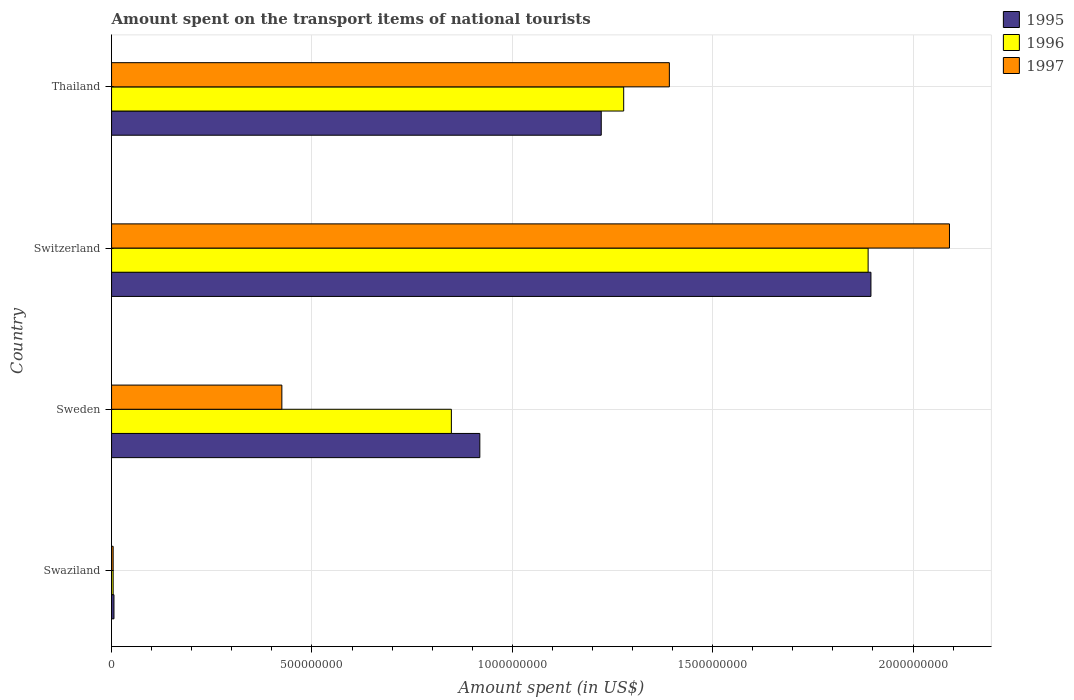How many different coloured bars are there?
Provide a succinct answer. 3. Are the number of bars on each tick of the Y-axis equal?
Your answer should be very brief. Yes. What is the label of the 3rd group of bars from the top?
Ensure brevity in your answer.  Sweden. In how many cases, is the number of bars for a given country not equal to the number of legend labels?
Offer a very short reply. 0. What is the amount spent on the transport items of national tourists in 1996 in Switzerland?
Keep it short and to the point. 1.89e+09. Across all countries, what is the maximum amount spent on the transport items of national tourists in 1997?
Your answer should be compact. 2.09e+09. In which country was the amount spent on the transport items of national tourists in 1997 maximum?
Provide a short and direct response. Switzerland. In which country was the amount spent on the transport items of national tourists in 1997 minimum?
Provide a succinct answer. Swaziland. What is the total amount spent on the transport items of national tourists in 1996 in the graph?
Your response must be concise. 4.02e+09. What is the difference between the amount spent on the transport items of national tourists in 1996 in Swaziland and that in Sweden?
Make the answer very short. -8.44e+08. What is the difference between the amount spent on the transport items of national tourists in 1997 in Thailand and the amount spent on the transport items of national tourists in 1996 in Switzerland?
Keep it short and to the point. -4.96e+08. What is the average amount spent on the transport items of national tourists in 1996 per country?
Your answer should be compact. 1.00e+09. What is the difference between the amount spent on the transport items of national tourists in 1995 and amount spent on the transport items of national tourists in 1996 in Sweden?
Make the answer very short. 7.10e+07. In how many countries, is the amount spent on the transport items of national tourists in 1997 greater than 2000000000 US$?
Offer a terse response. 1. What is the ratio of the amount spent on the transport items of national tourists in 1997 in Sweden to that in Thailand?
Keep it short and to the point. 0.31. What is the difference between the highest and the second highest amount spent on the transport items of national tourists in 1996?
Offer a terse response. 6.10e+08. What is the difference between the highest and the lowest amount spent on the transport items of national tourists in 1995?
Your answer should be very brief. 1.89e+09. What does the 3rd bar from the bottom in Swaziland represents?
Provide a succinct answer. 1997. Is it the case that in every country, the sum of the amount spent on the transport items of national tourists in 1997 and amount spent on the transport items of national tourists in 1995 is greater than the amount spent on the transport items of national tourists in 1996?
Offer a terse response. Yes. Are all the bars in the graph horizontal?
Offer a very short reply. Yes. Does the graph contain any zero values?
Provide a succinct answer. No. Does the graph contain grids?
Provide a short and direct response. Yes. Where does the legend appear in the graph?
Your response must be concise. Top right. How many legend labels are there?
Your answer should be compact. 3. What is the title of the graph?
Provide a succinct answer. Amount spent on the transport items of national tourists. Does "2007" appear as one of the legend labels in the graph?
Offer a very short reply. No. What is the label or title of the X-axis?
Provide a succinct answer. Amount spent (in US$). What is the label or title of the Y-axis?
Ensure brevity in your answer.  Country. What is the Amount spent (in US$) in 1995 in Swaziland?
Give a very brief answer. 6.00e+06. What is the Amount spent (in US$) in 1997 in Swaziland?
Offer a very short reply. 4.00e+06. What is the Amount spent (in US$) in 1995 in Sweden?
Your answer should be compact. 9.19e+08. What is the Amount spent (in US$) of 1996 in Sweden?
Provide a short and direct response. 8.48e+08. What is the Amount spent (in US$) in 1997 in Sweden?
Offer a terse response. 4.25e+08. What is the Amount spent (in US$) in 1995 in Switzerland?
Your answer should be compact. 1.90e+09. What is the Amount spent (in US$) of 1996 in Switzerland?
Your response must be concise. 1.89e+09. What is the Amount spent (in US$) of 1997 in Switzerland?
Keep it short and to the point. 2.09e+09. What is the Amount spent (in US$) of 1995 in Thailand?
Your response must be concise. 1.22e+09. What is the Amount spent (in US$) of 1996 in Thailand?
Make the answer very short. 1.28e+09. What is the Amount spent (in US$) of 1997 in Thailand?
Your response must be concise. 1.39e+09. Across all countries, what is the maximum Amount spent (in US$) in 1995?
Provide a short and direct response. 1.90e+09. Across all countries, what is the maximum Amount spent (in US$) in 1996?
Your answer should be compact. 1.89e+09. Across all countries, what is the maximum Amount spent (in US$) in 1997?
Your response must be concise. 2.09e+09. Across all countries, what is the minimum Amount spent (in US$) in 1997?
Your response must be concise. 4.00e+06. What is the total Amount spent (in US$) in 1995 in the graph?
Offer a very short reply. 4.04e+09. What is the total Amount spent (in US$) of 1996 in the graph?
Offer a terse response. 4.02e+09. What is the total Amount spent (in US$) in 1997 in the graph?
Your answer should be compact. 3.91e+09. What is the difference between the Amount spent (in US$) in 1995 in Swaziland and that in Sweden?
Your answer should be very brief. -9.13e+08. What is the difference between the Amount spent (in US$) in 1996 in Swaziland and that in Sweden?
Keep it short and to the point. -8.44e+08. What is the difference between the Amount spent (in US$) in 1997 in Swaziland and that in Sweden?
Offer a terse response. -4.21e+08. What is the difference between the Amount spent (in US$) in 1995 in Swaziland and that in Switzerland?
Your response must be concise. -1.89e+09. What is the difference between the Amount spent (in US$) in 1996 in Swaziland and that in Switzerland?
Ensure brevity in your answer.  -1.88e+09. What is the difference between the Amount spent (in US$) in 1997 in Swaziland and that in Switzerland?
Provide a succinct answer. -2.09e+09. What is the difference between the Amount spent (in US$) in 1995 in Swaziland and that in Thailand?
Ensure brevity in your answer.  -1.22e+09. What is the difference between the Amount spent (in US$) in 1996 in Swaziland and that in Thailand?
Your answer should be compact. -1.27e+09. What is the difference between the Amount spent (in US$) in 1997 in Swaziland and that in Thailand?
Provide a succinct answer. -1.39e+09. What is the difference between the Amount spent (in US$) of 1995 in Sweden and that in Switzerland?
Provide a short and direct response. -9.76e+08. What is the difference between the Amount spent (in US$) in 1996 in Sweden and that in Switzerland?
Offer a terse response. -1.04e+09. What is the difference between the Amount spent (in US$) of 1997 in Sweden and that in Switzerland?
Keep it short and to the point. -1.67e+09. What is the difference between the Amount spent (in US$) in 1995 in Sweden and that in Thailand?
Your answer should be compact. -3.03e+08. What is the difference between the Amount spent (in US$) in 1996 in Sweden and that in Thailand?
Offer a very short reply. -4.30e+08. What is the difference between the Amount spent (in US$) of 1997 in Sweden and that in Thailand?
Offer a terse response. -9.67e+08. What is the difference between the Amount spent (in US$) of 1995 in Switzerland and that in Thailand?
Your answer should be compact. 6.73e+08. What is the difference between the Amount spent (in US$) in 1996 in Switzerland and that in Thailand?
Your response must be concise. 6.10e+08. What is the difference between the Amount spent (in US$) of 1997 in Switzerland and that in Thailand?
Your answer should be very brief. 6.99e+08. What is the difference between the Amount spent (in US$) of 1995 in Swaziland and the Amount spent (in US$) of 1996 in Sweden?
Provide a short and direct response. -8.42e+08. What is the difference between the Amount spent (in US$) of 1995 in Swaziland and the Amount spent (in US$) of 1997 in Sweden?
Give a very brief answer. -4.19e+08. What is the difference between the Amount spent (in US$) of 1996 in Swaziland and the Amount spent (in US$) of 1997 in Sweden?
Your answer should be very brief. -4.21e+08. What is the difference between the Amount spent (in US$) in 1995 in Swaziland and the Amount spent (in US$) in 1996 in Switzerland?
Ensure brevity in your answer.  -1.88e+09. What is the difference between the Amount spent (in US$) of 1995 in Swaziland and the Amount spent (in US$) of 1997 in Switzerland?
Provide a short and direct response. -2.08e+09. What is the difference between the Amount spent (in US$) in 1996 in Swaziland and the Amount spent (in US$) in 1997 in Switzerland?
Your answer should be compact. -2.09e+09. What is the difference between the Amount spent (in US$) in 1995 in Swaziland and the Amount spent (in US$) in 1996 in Thailand?
Offer a very short reply. -1.27e+09. What is the difference between the Amount spent (in US$) in 1995 in Swaziland and the Amount spent (in US$) in 1997 in Thailand?
Make the answer very short. -1.39e+09. What is the difference between the Amount spent (in US$) of 1996 in Swaziland and the Amount spent (in US$) of 1997 in Thailand?
Your answer should be very brief. -1.39e+09. What is the difference between the Amount spent (in US$) in 1995 in Sweden and the Amount spent (in US$) in 1996 in Switzerland?
Provide a short and direct response. -9.69e+08. What is the difference between the Amount spent (in US$) in 1995 in Sweden and the Amount spent (in US$) in 1997 in Switzerland?
Offer a terse response. -1.17e+09. What is the difference between the Amount spent (in US$) in 1996 in Sweden and the Amount spent (in US$) in 1997 in Switzerland?
Provide a succinct answer. -1.24e+09. What is the difference between the Amount spent (in US$) in 1995 in Sweden and the Amount spent (in US$) in 1996 in Thailand?
Your answer should be very brief. -3.59e+08. What is the difference between the Amount spent (in US$) in 1995 in Sweden and the Amount spent (in US$) in 1997 in Thailand?
Provide a short and direct response. -4.73e+08. What is the difference between the Amount spent (in US$) in 1996 in Sweden and the Amount spent (in US$) in 1997 in Thailand?
Provide a short and direct response. -5.44e+08. What is the difference between the Amount spent (in US$) in 1995 in Switzerland and the Amount spent (in US$) in 1996 in Thailand?
Give a very brief answer. 6.17e+08. What is the difference between the Amount spent (in US$) of 1995 in Switzerland and the Amount spent (in US$) of 1997 in Thailand?
Your answer should be compact. 5.03e+08. What is the difference between the Amount spent (in US$) of 1996 in Switzerland and the Amount spent (in US$) of 1997 in Thailand?
Make the answer very short. 4.96e+08. What is the average Amount spent (in US$) in 1995 per country?
Offer a terse response. 1.01e+09. What is the average Amount spent (in US$) in 1996 per country?
Offer a very short reply. 1.00e+09. What is the average Amount spent (in US$) of 1997 per country?
Your answer should be compact. 9.78e+08. What is the difference between the Amount spent (in US$) of 1995 and Amount spent (in US$) of 1996 in Swaziland?
Give a very brief answer. 2.00e+06. What is the difference between the Amount spent (in US$) in 1996 and Amount spent (in US$) in 1997 in Swaziland?
Provide a short and direct response. 0. What is the difference between the Amount spent (in US$) in 1995 and Amount spent (in US$) in 1996 in Sweden?
Make the answer very short. 7.10e+07. What is the difference between the Amount spent (in US$) in 1995 and Amount spent (in US$) in 1997 in Sweden?
Your answer should be very brief. 4.94e+08. What is the difference between the Amount spent (in US$) of 1996 and Amount spent (in US$) of 1997 in Sweden?
Offer a terse response. 4.23e+08. What is the difference between the Amount spent (in US$) in 1995 and Amount spent (in US$) in 1997 in Switzerland?
Make the answer very short. -1.96e+08. What is the difference between the Amount spent (in US$) of 1996 and Amount spent (in US$) of 1997 in Switzerland?
Provide a short and direct response. -2.03e+08. What is the difference between the Amount spent (in US$) of 1995 and Amount spent (in US$) of 1996 in Thailand?
Your answer should be compact. -5.60e+07. What is the difference between the Amount spent (in US$) in 1995 and Amount spent (in US$) in 1997 in Thailand?
Offer a terse response. -1.70e+08. What is the difference between the Amount spent (in US$) of 1996 and Amount spent (in US$) of 1997 in Thailand?
Provide a short and direct response. -1.14e+08. What is the ratio of the Amount spent (in US$) of 1995 in Swaziland to that in Sweden?
Ensure brevity in your answer.  0.01. What is the ratio of the Amount spent (in US$) in 1996 in Swaziland to that in Sweden?
Provide a succinct answer. 0. What is the ratio of the Amount spent (in US$) in 1997 in Swaziland to that in Sweden?
Your response must be concise. 0.01. What is the ratio of the Amount spent (in US$) of 1995 in Swaziland to that in Switzerland?
Give a very brief answer. 0. What is the ratio of the Amount spent (in US$) of 1996 in Swaziland to that in Switzerland?
Your answer should be very brief. 0. What is the ratio of the Amount spent (in US$) of 1997 in Swaziland to that in Switzerland?
Your response must be concise. 0. What is the ratio of the Amount spent (in US$) of 1995 in Swaziland to that in Thailand?
Give a very brief answer. 0. What is the ratio of the Amount spent (in US$) in 1996 in Swaziland to that in Thailand?
Offer a terse response. 0. What is the ratio of the Amount spent (in US$) of 1997 in Swaziland to that in Thailand?
Provide a short and direct response. 0. What is the ratio of the Amount spent (in US$) of 1995 in Sweden to that in Switzerland?
Your response must be concise. 0.48. What is the ratio of the Amount spent (in US$) in 1996 in Sweden to that in Switzerland?
Your answer should be compact. 0.45. What is the ratio of the Amount spent (in US$) of 1997 in Sweden to that in Switzerland?
Give a very brief answer. 0.2. What is the ratio of the Amount spent (in US$) of 1995 in Sweden to that in Thailand?
Provide a short and direct response. 0.75. What is the ratio of the Amount spent (in US$) of 1996 in Sweden to that in Thailand?
Give a very brief answer. 0.66. What is the ratio of the Amount spent (in US$) in 1997 in Sweden to that in Thailand?
Offer a very short reply. 0.31. What is the ratio of the Amount spent (in US$) of 1995 in Switzerland to that in Thailand?
Your response must be concise. 1.55. What is the ratio of the Amount spent (in US$) in 1996 in Switzerland to that in Thailand?
Keep it short and to the point. 1.48. What is the ratio of the Amount spent (in US$) of 1997 in Switzerland to that in Thailand?
Your answer should be very brief. 1.5. What is the difference between the highest and the second highest Amount spent (in US$) in 1995?
Make the answer very short. 6.73e+08. What is the difference between the highest and the second highest Amount spent (in US$) in 1996?
Ensure brevity in your answer.  6.10e+08. What is the difference between the highest and the second highest Amount spent (in US$) in 1997?
Provide a succinct answer. 6.99e+08. What is the difference between the highest and the lowest Amount spent (in US$) in 1995?
Give a very brief answer. 1.89e+09. What is the difference between the highest and the lowest Amount spent (in US$) in 1996?
Give a very brief answer. 1.88e+09. What is the difference between the highest and the lowest Amount spent (in US$) of 1997?
Provide a succinct answer. 2.09e+09. 